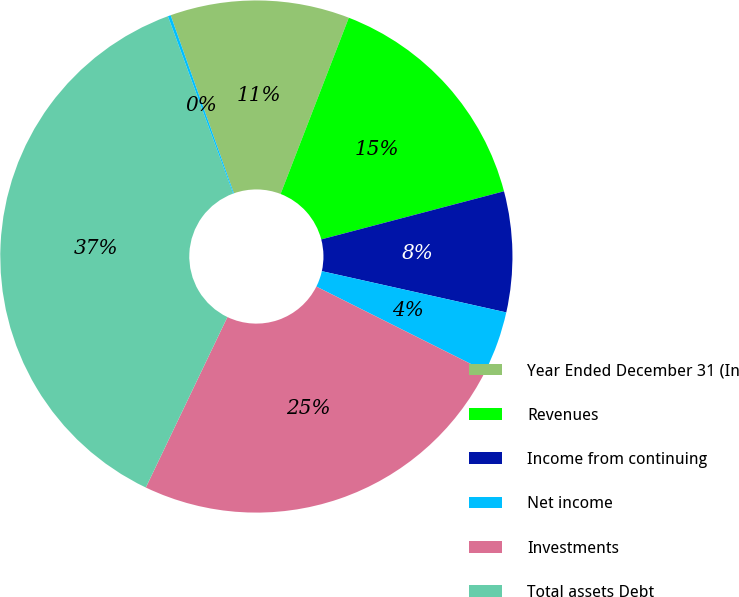Convert chart to OTSL. <chart><loc_0><loc_0><loc_500><loc_500><pie_chart><fcel>Year Ended December 31 (In<fcel>Revenues<fcel>Income from continuing<fcel>Net income<fcel>Investments<fcel>Total assets Debt<fcel>Shares outstanding<nl><fcel>11.31%<fcel>15.02%<fcel>7.6%<fcel>3.89%<fcel>24.71%<fcel>37.28%<fcel>0.18%<nl></chart> 